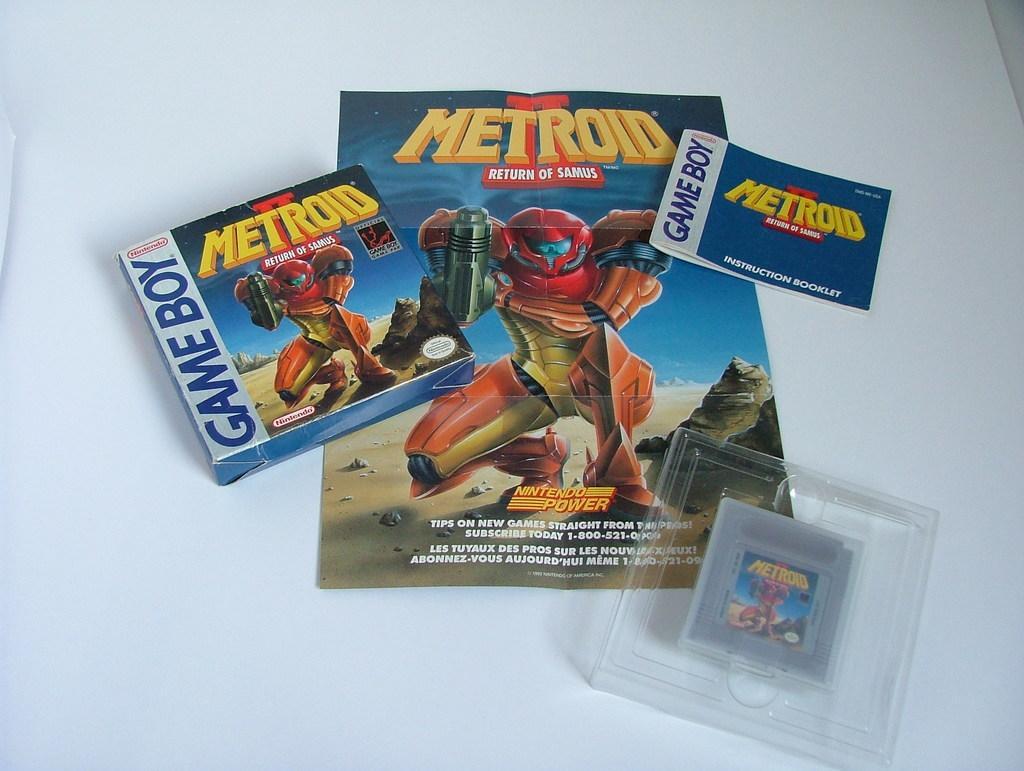Can you describe this image briefly? In this image I can see the box, pamphlet, book and the plastic box. These are on the white color surface. 